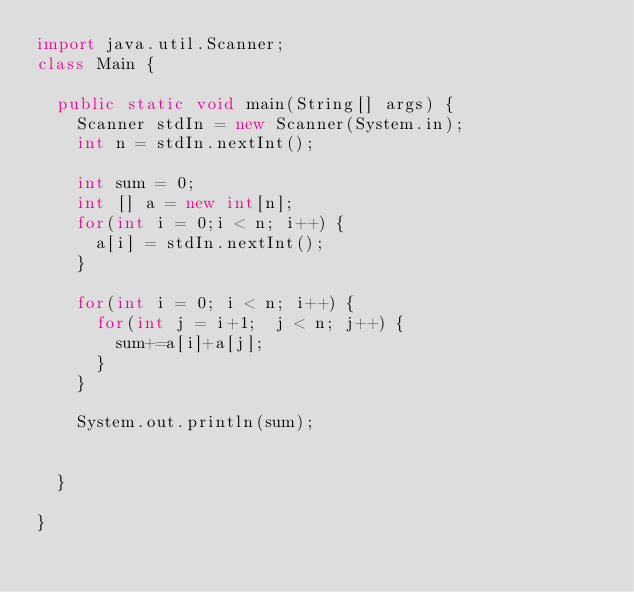<code> <loc_0><loc_0><loc_500><loc_500><_Java_>import java.util.Scanner;
class Main {

	public static void main(String[] args) {
		Scanner stdIn = new Scanner(System.in);
		int n = stdIn.nextInt();

		int sum = 0;
		int [] a = new int[n];
		for(int i = 0;i < n; i++) {
			a[i] = stdIn.nextInt();
		}

		for(int i = 0; i < n; i++) {
			for(int j = i+1;  j < n; j++) {
				sum+=a[i]+a[j];
			}
		}

		System.out.println(sum);


	}

}
</code> 